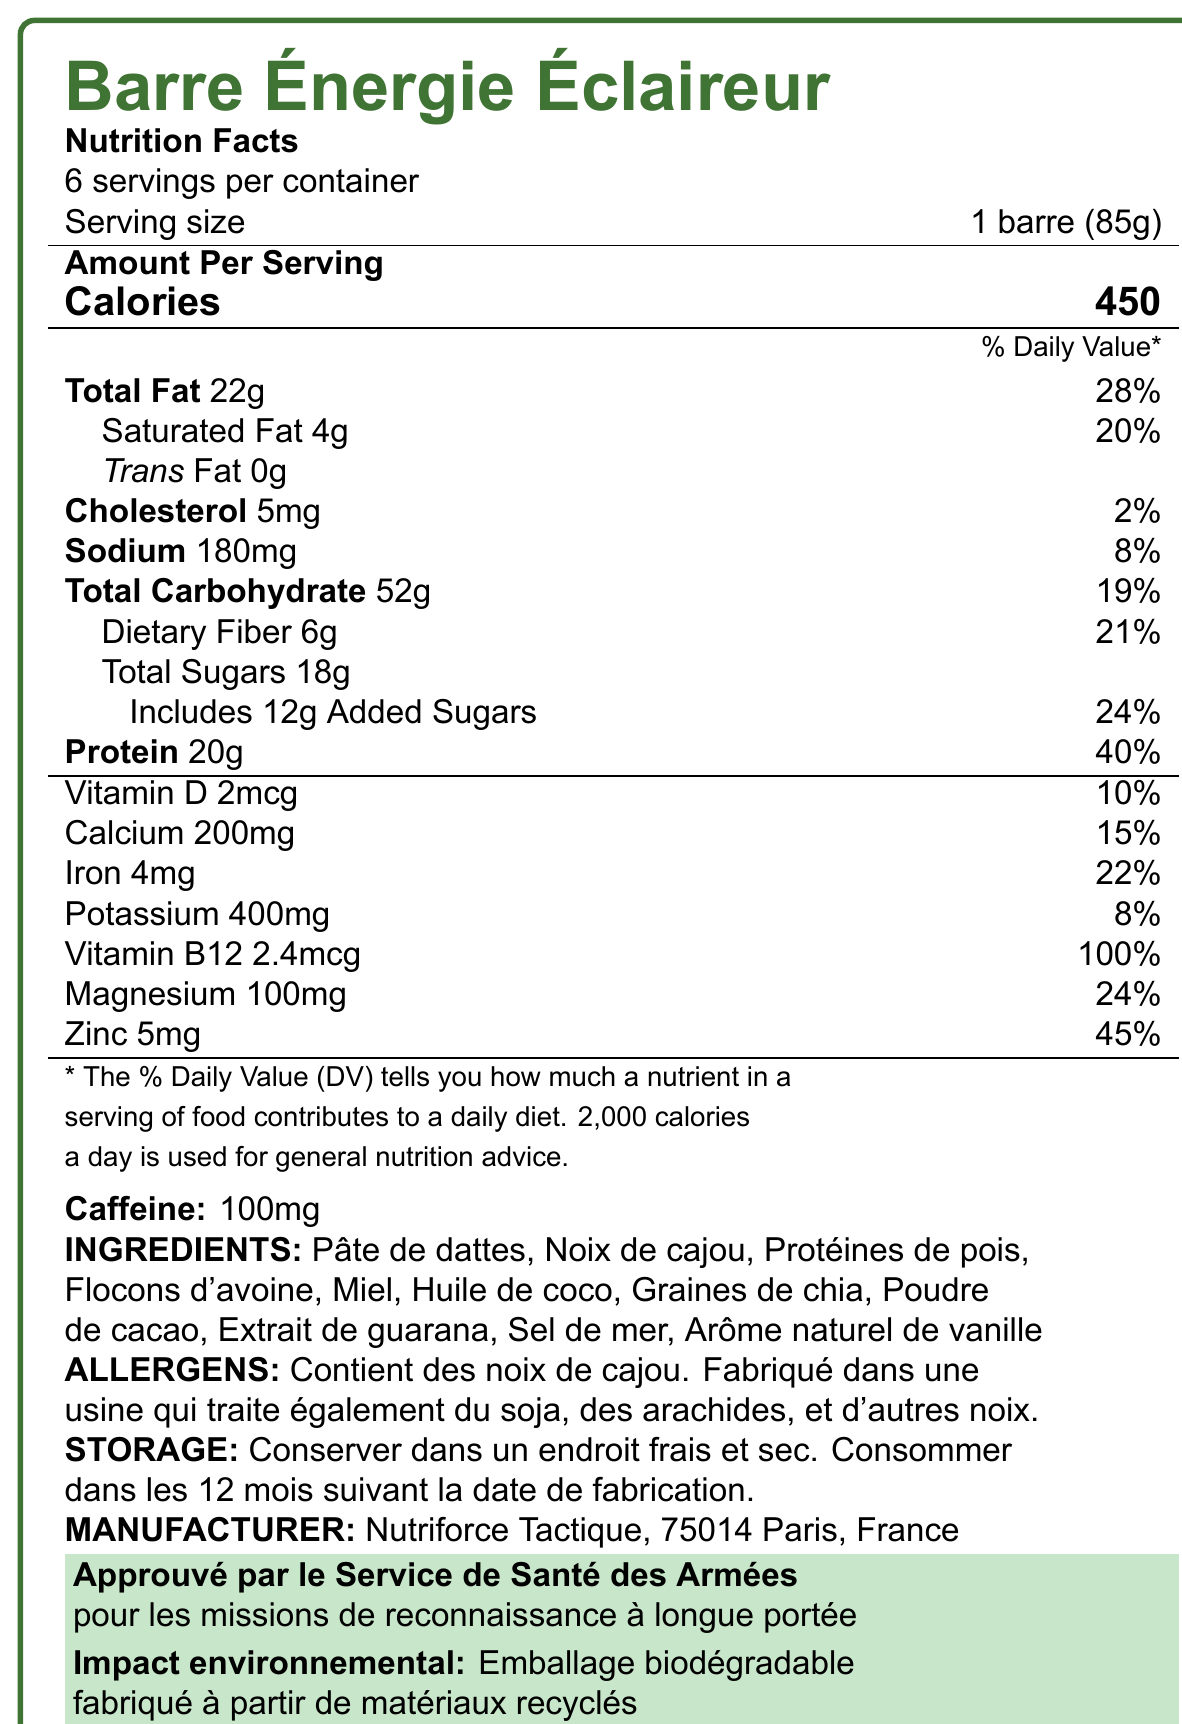what is the name of the product? The document clearly states "Barre Énergie Éclaireur" as the product name in the first line.
Answer: Barre Énergie Éclaireur what is the serving size of the product? The serving size is mentioned in the document as "1 barre (85g)".
Answer: 1 barre (85g) how many calories are in one serving? The number of calories per serving is listed as 450 in the "Amount Per Serving" section.
Answer: 450 how much total fat is there per serving and what percentage of the daily value does it represent? The document states "Total Fat 22g" and "28%" as the daily value percentage.
Answer: 22g, 28% what are the allergens listed in the document? The allergens section lists "Contient des noix de cajou" and further details about processing in a factory that handles other nuts and soy.
Answer: Contient des noix de cajou. Fabriqué dans une usine qui traite également du soja, des arachides, et d'autres noix. does the product contain any trans fat? The document explicitly states "Trans Fat 0g", indicating no trans fat.
Answer: No how much protein does one serving contain? The "Amount Per Serving" section lists "Protein 20g".
Answer: 20g how much caffeine is in each serving? A specific section is dedicated to caffeine content, stating "Caffeine: 100mg".
Answer: 100mg which company manufactures this product? The manufacturer's information is listed as "Nutriforce Tactique, 75014 Paris, France".
Answer: Nutriforce Tactique what percentage of the daily value for vitamin B12 does one serving provide? A. 10% B. 15% C. 45% D. 100% The document states "Vitamin B12 2.4mcg" with a daily value of "100%".
Answer: D what is the daily value percentage for dietary fiber in one serving? A. 19% B. 21% C. 24% D. 28% The document lists "Dietary Fiber 6g" with a daily value of "21%".
Answer: B is this product approved by any military organization? The document mentions "Approuvé par le Service de Santé des Armées pour les missions de reconnaissance à longue portée".
Answer: Yes what is the main idea of this document? The document serves to convey comprehensive nutritional, manufacturing, and approval information regarding the energy bar.
Answer: This document is a nutrition facts label for "Barre Énergie Éclaireur", a high-energy food bar developed for long-range reconnaissance missions. It provides detailed nutritional information, ingredients, allergens, storage instructions, manufacturer details, military approval status, and environmental impact. what ingredients are used in the bar? The ingredients are listed clearly in the document.
Answer: Pâte de dattes, Noix de cajou, Protéines de pois, Flocons d'avoine, Miel, Huile de coco, Graines de chia, Poudre de cacao, Extrait de guarana, Sel de mer, Arôme naturel de vanille which nutrient has the highest daily value percentage? The daily value percentage for Vitamin B12 is 100%, which is the highest among the listed nutrients.
Answer: Vitamin B12 how should the product be stored, and what is the shelf life? The storage instructions advise to "Conserver dans un endroit frais et sec" and state a shelf life of "12 mois".
Answer: Conserver dans un endroit frais et sec. Consommer dans les 12 mois suivant la date de fabrication. who is the target audience for this product based on the document? The document specifies "Approuvé par le Service de Santé des Armées pour les missions de reconnaissance à longue portée".
Answer: Soldiers on long-range reconnaissance missions what is the potassium content in one serving? The potassium content is listed as "Potassium 400mg".
Answer: 400mg how many servings are there per container of this product? The document mentions "6 servings per container".
Answer: 6 which nutrient in the bar provides the least percentage of daily value? At "2%", cholesterol provides the least daily value percentage among the listed nutrients.
Answer: Cholesterol how much calcium is in one serving and what percentage of the daily value does it represent? The document lists "Calcium 200mg" and "15%" daily value.
Answer: 200mg, 15% does the packaging have any environmental impact considerations? The document states, "Emballage biodégradable fabriqué à partir de matériaux recyclés", indicating environmental impact considerations.
Answer: Yes what is the protein source in the ingredients? The source of protein listed in the ingredients is "Protéines de pois".
Answer: Protéines de pois how much saturated fat is in a single serving? The document mentions "Saturated Fat 4g".
Answer: 4g what is the exact address of the manufacturer? The document provides "Nutriforce Tactique, 75014 Paris, France" as the manufacturer's address.
Answer: 75014 Paris, France what is the sodium content per serving and its percentage of daily value? The sodium content is listed as "180mg" with an "8%" daily value.
Answer: 180mg, 8% what are the specific flavors mentioned in the ingredients? The document mentions "Arôme naturel de vanille."
Answer: Natural vanilla flavor does the energy bar contain any caffeine? The document lists "Caffeine: 100mg", indicating the presence of caffeine.
Answer: Yes how much magnesium is in the bar and what is its daily value percentage? The document lists "Magnesium 100mg" and "24%" as the daily value.
Answer: 100mg, 24% who approved this product for military use? The approval comes from "Service de Santé des Armées" for reconnaissance missions.
Answer: Service de Santé des Armées what is the total carbohydrate content per serving and its percentage of daily value? The carbohydrate content is "Total Carbohydrate 52g" with "19%" daily value.
Answer: 52g, 19% how many grams of added sugars are in one serving? The document lists "Includes 12g Added Sugars".
Answer: 12g how much iron is in one serving and its daily value percentage? The document states "Iron 4mg" with "22%" daily value.
Answer: 4mg, 22% 